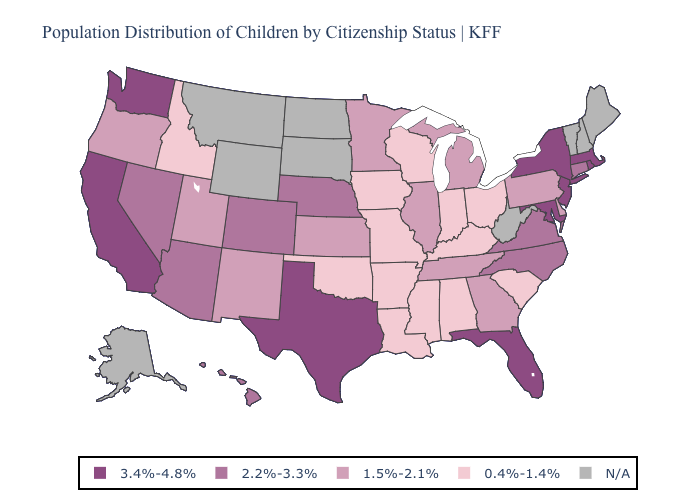Does Massachusetts have the highest value in the Northeast?
Answer briefly. Yes. Does the first symbol in the legend represent the smallest category?
Be succinct. No. Name the states that have a value in the range 2.2%-3.3%?
Give a very brief answer. Arizona, Colorado, Connecticut, Hawaii, Nebraska, Nevada, North Carolina, Virginia. Which states have the lowest value in the South?
Quick response, please. Alabama, Arkansas, Kentucky, Louisiana, Mississippi, Oklahoma, South Carolina. Name the states that have a value in the range 1.5%-2.1%?
Keep it brief. Delaware, Georgia, Illinois, Kansas, Michigan, Minnesota, New Mexico, Oregon, Pennsylvania, Tennessee, Utah. Name the states that have a value in the range 2.2%-3.3%?
Quick response, please. Arizona, Colorado, Connecticut, Hawaii, Nebraska, Nevada, North Carolina, Virginia. Does Idaho have the lowest value in the USA?
Write a very short answer. Yes. What is the value of Kansas?
Be succinct. 1.5%-2.1%. Name the states that have a value in the range 0.4%-1.4%?
Give a very brief answer. Alabama, Arkansas, Idaho, Indiana, Iowa, Kentucky, Louisiana, Mississippi, Missouri, Ohio, Oklahoma, South Carolina, Wisconsin. What is the highest value in the USA?
Be succinct. 3.4%-4.8%. What is the value of Missouri?
Quick response, please. 0.4%-1.4%. What is the value of Alaska?
Write a very short answer. N/A. What is the value of Florida?
Answer briefly. 3.4%-4.8%. What is the lowest value in the Northeast?
Give a very brief answer. 1.5%-2.1%. 